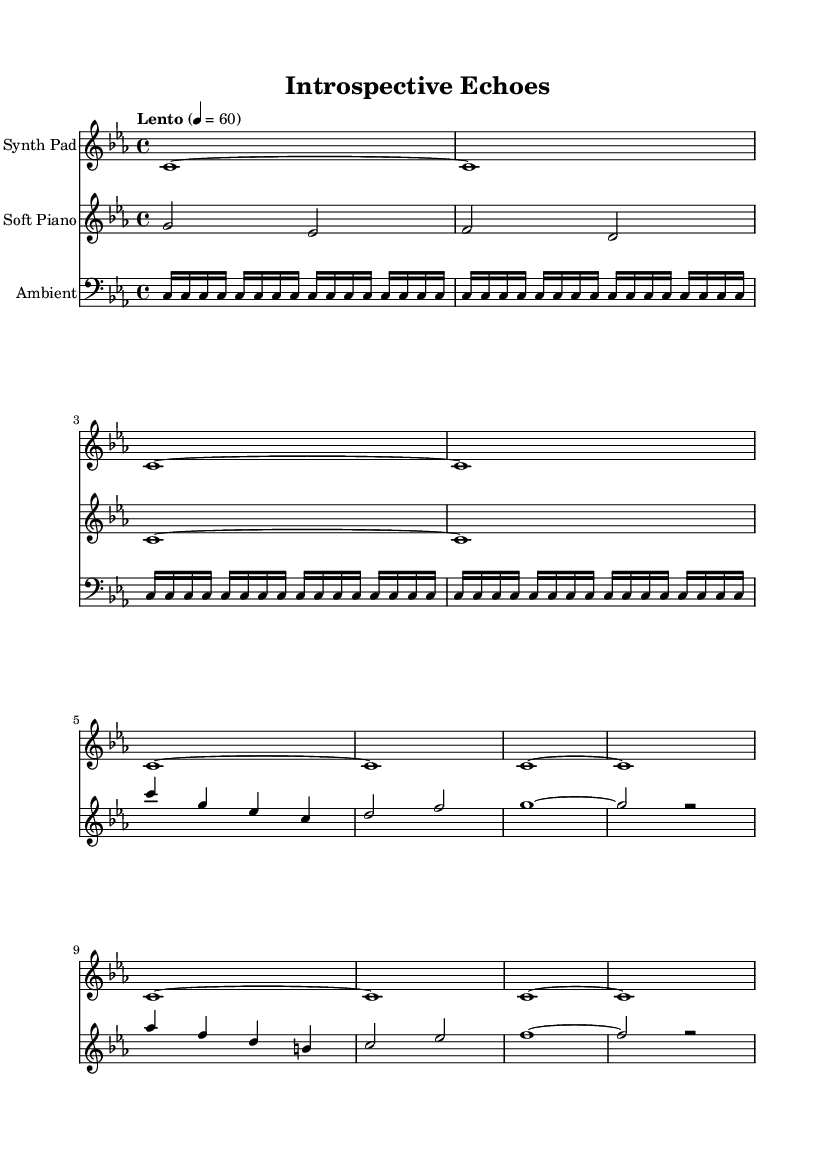what is the key signature of this music? The key signature is C minor, which has three flats (B♭, E♭, and A♭). This can be identified at the beginning of the staff before the first note.
Answer: C minor what is the time signature of this music? The time signature is 4/4, indicated at the beginning of the score. This means there are four beats in each measure and the quarter note gets one beat.
Answer: 4/4 what is the tempo marking for this piece? The tempo marking is "Lento," which indicates a slow tempo. This can be seen alongside the metronome marking at the beginning of the score, set to 60 beats per minute.
Answer: Lento how many parts are in the score? The score contains three distinct parts: Synth Pad, Soft Piano, and Ambient. Each part is represented by a separate staff in the score layout.
Answer: 3 what is the dynamic marking for the Soft Piano part? There are no explicit dynamic markings provided in the score; thus, the performance can be guided by the interpretative choices of the performer, usually leaning towards a gentle touch for ambient music.
Answer: None specified which musical element contributes most to the ambient textures? The ambient textures are primarily contributed by the repeating sixteenth notes in the bass clef, which create a continuous and immersive sound environment. This can be recognized by the line of continuous notes labeled as 'ambientTextures.'
Answer: Repeated sixteenth notes 